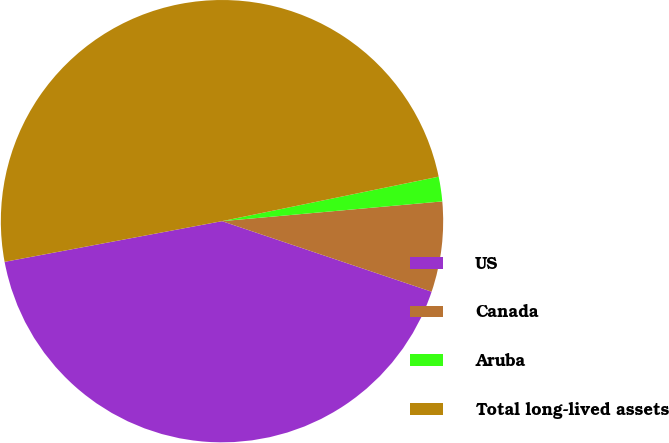<chart> <loc_0><loc_0><loc_500><loc_500><pie_chart><fcel>US<fcel>Canada<fcel>Aruba<fcel>Total long-lived assets<nl><fcel>41.89%<fcel>6.59%<fcel>1.8%<fcel>49.72%<nl></chart> 